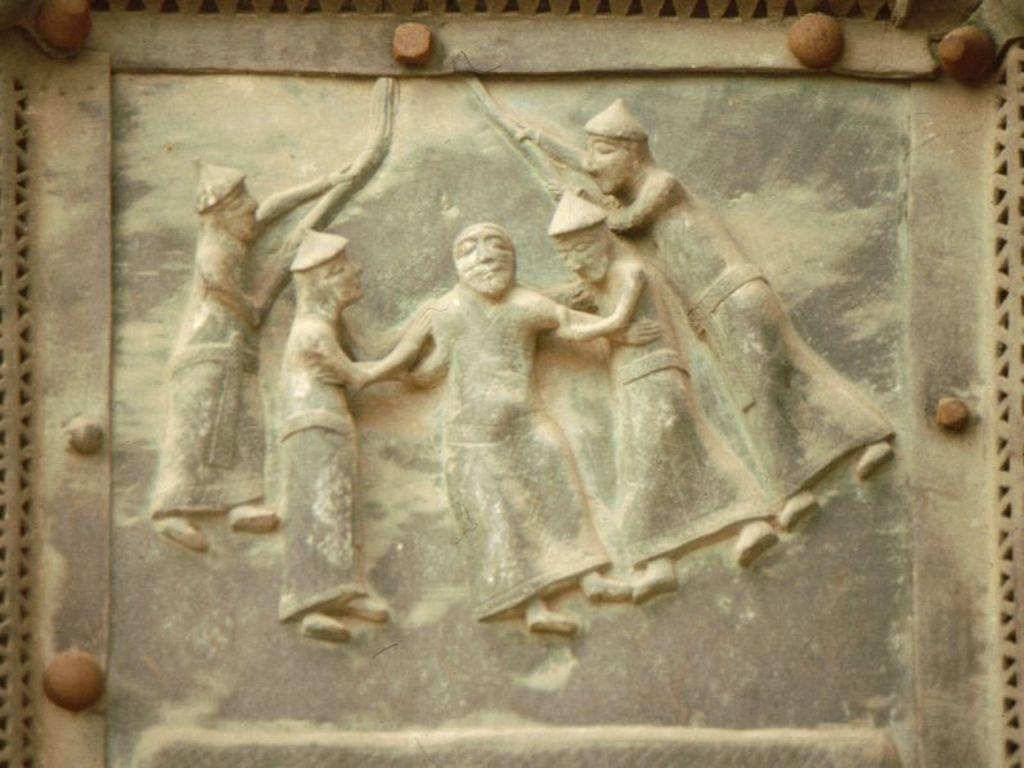What is the main subject of the image? There is a sculpture in the image. How many bears can be seen interacting with the sculpture in the image? There are no bears present in the image; it features a sculpture. What type of bucket is used to collect the end of the sculpture in the image? There is no bucket or end of the sculpture present in the image. 